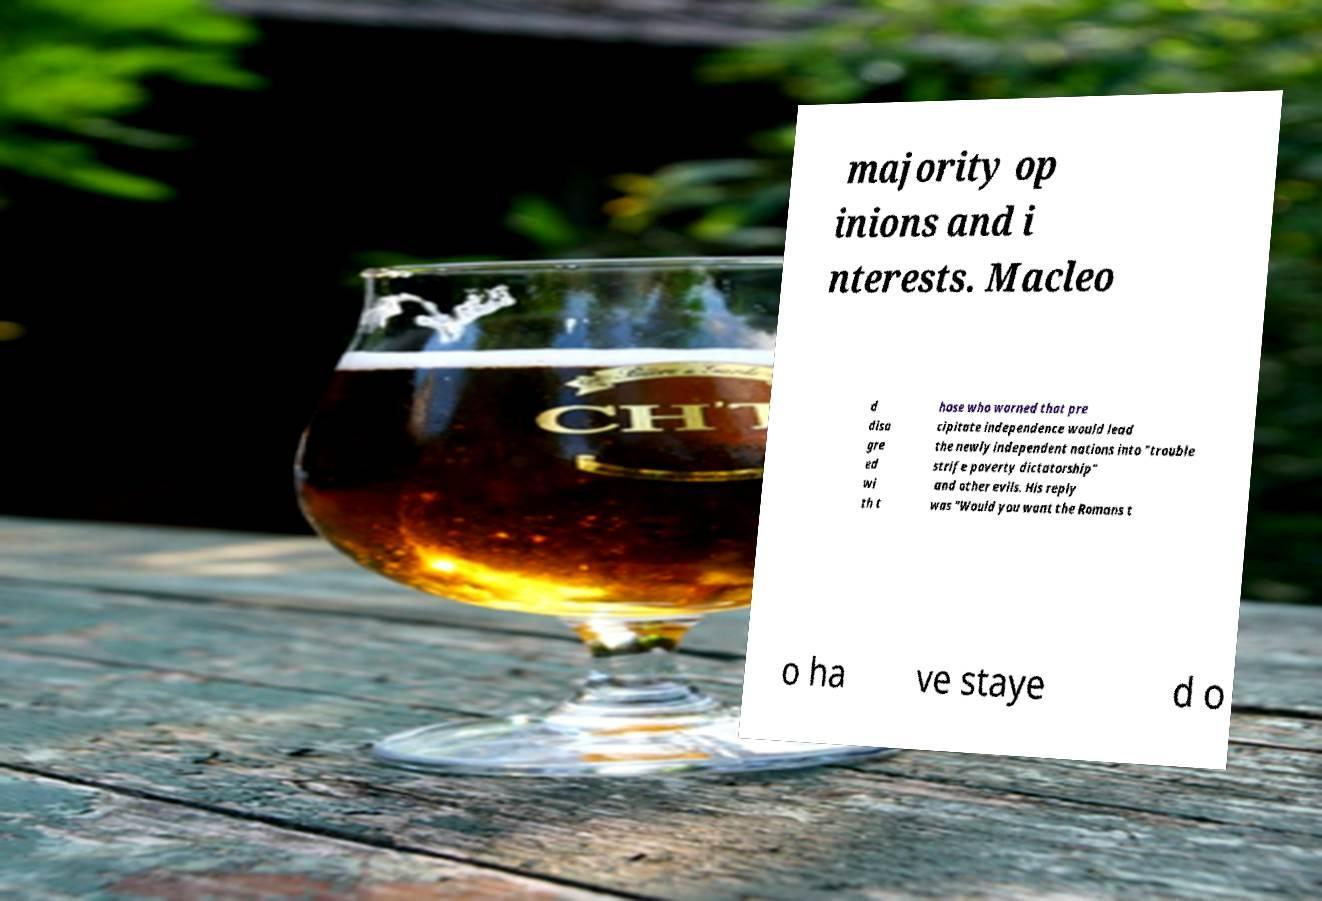Please identify and transcribe the text found in this image. majority op inions and i nterests. Macleo d disa gre ed wi th t hose who warned that pre cipitate independence would lead the newly independent nations into "trouble strife poverty dictatorship" and other evils. His reply was "Would you want the Romans t o ha ve staye d o 